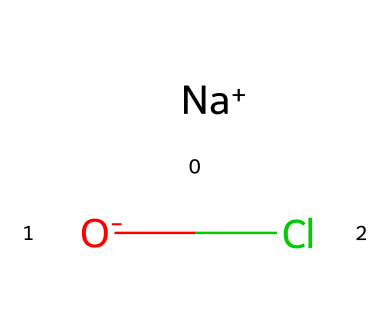What is the molecular formula of this chemical? The chemical is represented by the SMILES notation [Na+].[O-]Cl, which indicates that it contains sodium (Na), oxygen (O), and chlorine (Cl) atoms. The molecular formula combines these elements, leading to NaClO.
Answer: NaClO How many atoms are present in this molecule? The SMILES representation shows three distinct atoms: one sodium (Na), one oxygen (O), and one chlorine (Cl). Thus, there are three atoms in total.
Answer: 3 What type of ion is sodium in this compound? The notation [Na+] indicates that the sodium ion carries a positive charge, meaning it is a cation. Therefore, sodium is a cation in this compound.
Answer: cation What is the oxidation state of chlorine in this molecule? To determine the oxidation state of chlorine in NaClO, we note that sodium has a charge of +1, and oxygen has a common oxidation state of -2. Therefore, for the compound to be neutral, chlorine must have an oxidation state of +1.
Answer: +1 Is this compound an oxidizing agent? Chlorine typically acts as an oxidizing agent due to its high electronegativity, which often allows it to gain electrons during reactions. Therefore, this compound can be considered an oxidizing agent.
Answer: yes What role does this compound play in public health initiatives? Sodium hypochlorite (the active component represented by NaClO) is commonly used as a disinfectant, making it crucial for cleaning and sanitizing in public health initiatives.
Answer: disinfectant 